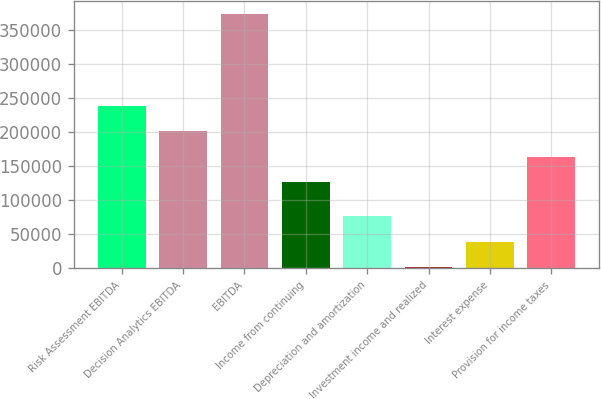Convert chart to OTSL. <chart><loc_0><loc_0><loc_500><loc_500><bar_chart><fcel>Risk Assessment EBITDA<fcel>Decision Analytics EBITDA<fcel>EBITDA<fcel>Income from continuing<fcel>Depreciation and amortization<fcel>Investment income and realized<fcel>Interest expense<fcel>Provision for income taxes<nl><fcel>237935<fcel>200828<fcel>373206<fcel>126614<fcel>76350.8<fcel>2137<fcel>39243.9<fcel>163721<nl></chart> 